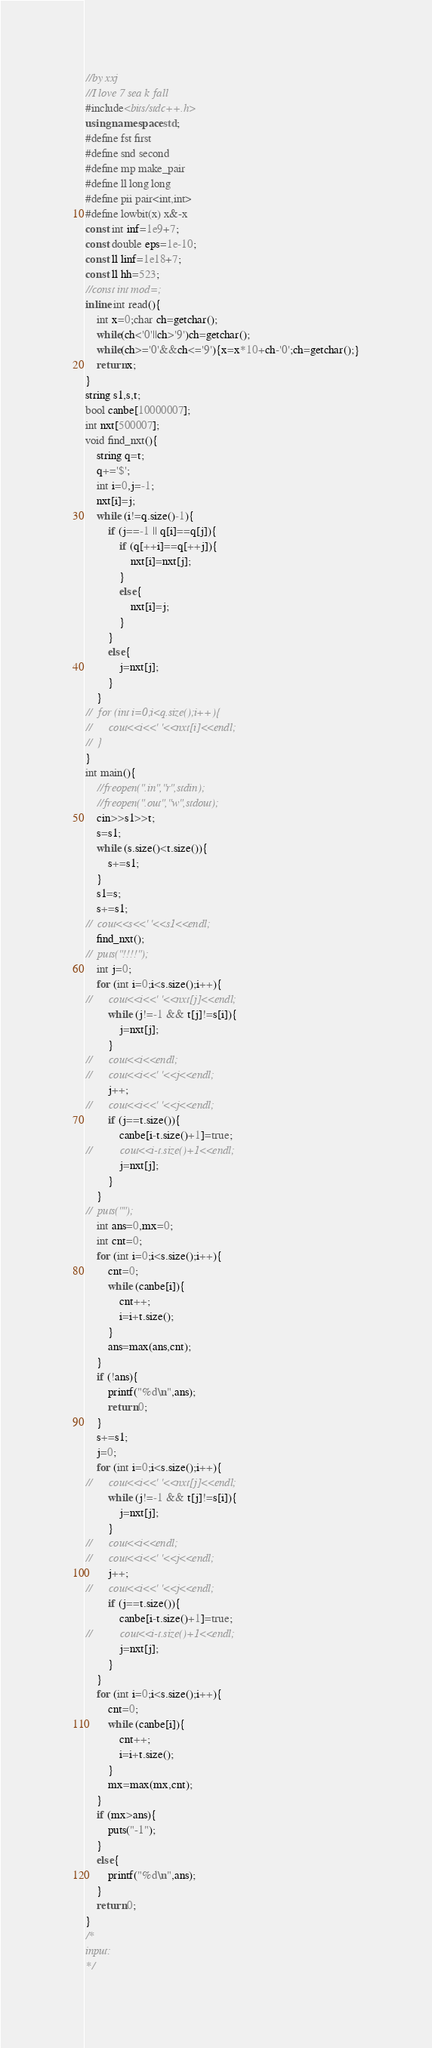<code> <loc_0><loc_0><loc_500><loc_500><_C++_>//by xxj
//I love 7 sea k fall
#include<bits/stdc++.h>
using namespace std;
#define fst first
#define snd second
#define mp make_pair
#define ll long long
#define pii pair<int,int>
#define lowbit(x) x&-x
const int inf=1e9+7;
const double eps=1e-10;
const ll linf=1e18+7;
const ll hh=523;
//const int mod=;
inline int read(){
    int x=0;char ch=getchar();
    while(ch<'0'||ch>'9')ch=getchar();
    while(ch>='0'&&ch<='9'){x=x*10+ch-'0';ch=getchar();}
    return x;
}
string s1,s,t;
bool canbe[10000007];
int nxt[500007];
void find_nxt(){
	string q=t;
	q+='$';
	int i=0,j=-1;
	nxt[i]=j;
	while (i!=q.size()-1){
		if (j==-1 || q[i]==q[j]){
			if (q[++i]==q[++j]){
				nxt[i]=nxt[j];
			}
			else{
				nxt[i]=j;
			}
		}
		else{
			j=nxt[j];
		}
	}
//	for (int i=0;i<q.size();i++){
//		cout<<i<<' '<<nxt[i]<<endl;
//	}
}
int main(){
	//freopen(".in","r",stdin);
	//freopen(".out","w",stdout);
	cin>>s1>>t;
	s=s1;
	while (s.size()<t.size()){
		s+=s1;
	}
	s1=s; 
	s+=s1;
//	cout<<s<<' '<<s1<<endl;
	find_nxt();
//	puts("!!!!");
	int j=0;
	for (int i=0;i<s.size();i++){
//		cout<<i<<' '<<nxt[j]<<endl;
		while (j!=-1 && t[j]!=s[i]){
			j=nxt[j];
		}
//		cout<<i<<endl;
//		cout<<i<<' '<<j<<endl;
		j++;
//		cout<<i<<' '<<j<<endl;
		if (j==t.size()){
			canbe[i-t.size()+1]=true;
//			cout<<i-t.size()+1<<endl;
			j=nxt[j];
		}
	}
//	puts("");
	int ans=0,mx=0;
	int cnt=0;
	for (int i=0;i<s.size();i++){
		cnt=0;
		while (canbe[i]){
			cnt++;
			i=i+t.size(); 
		}
		ans=max(ans,cnt);
	}
	if (!ans){
		printf("%d\n",ans);
		return 0;
	}
	s+=s1;
	j=0;
	for (int i=0;i<s.size();i++){
//		cout<<i<<' '<<nxt[j]<<endl;
		while (j!=-1 && t[j]!=s[i]){
			j=nxt[j];
		}
//		cout<<i<<endl;
//		cout<<i<<' '<<j<<endl;
		j++;
//		cout<<i<<' '<<j<<endl;
		if (j==t.size()){
			canbe[i-t.size()+1]=true;
//			cout<<i-t.size()+1<<endl;
			j=nxt[j];
		}
	}
	for (int i=0;i<s.size();i++){
		cnt=0;
		while (canbe[i]){
			cnt++;
			i=i+t.size(); 
		}
		mx=max(mx,cnt);
	}
	if (mx>ans){
		puts("-1");
	}
	else{
		printf("%d\n",ans);
	}
	return 0;
}
/*
input:
*/
</code> 